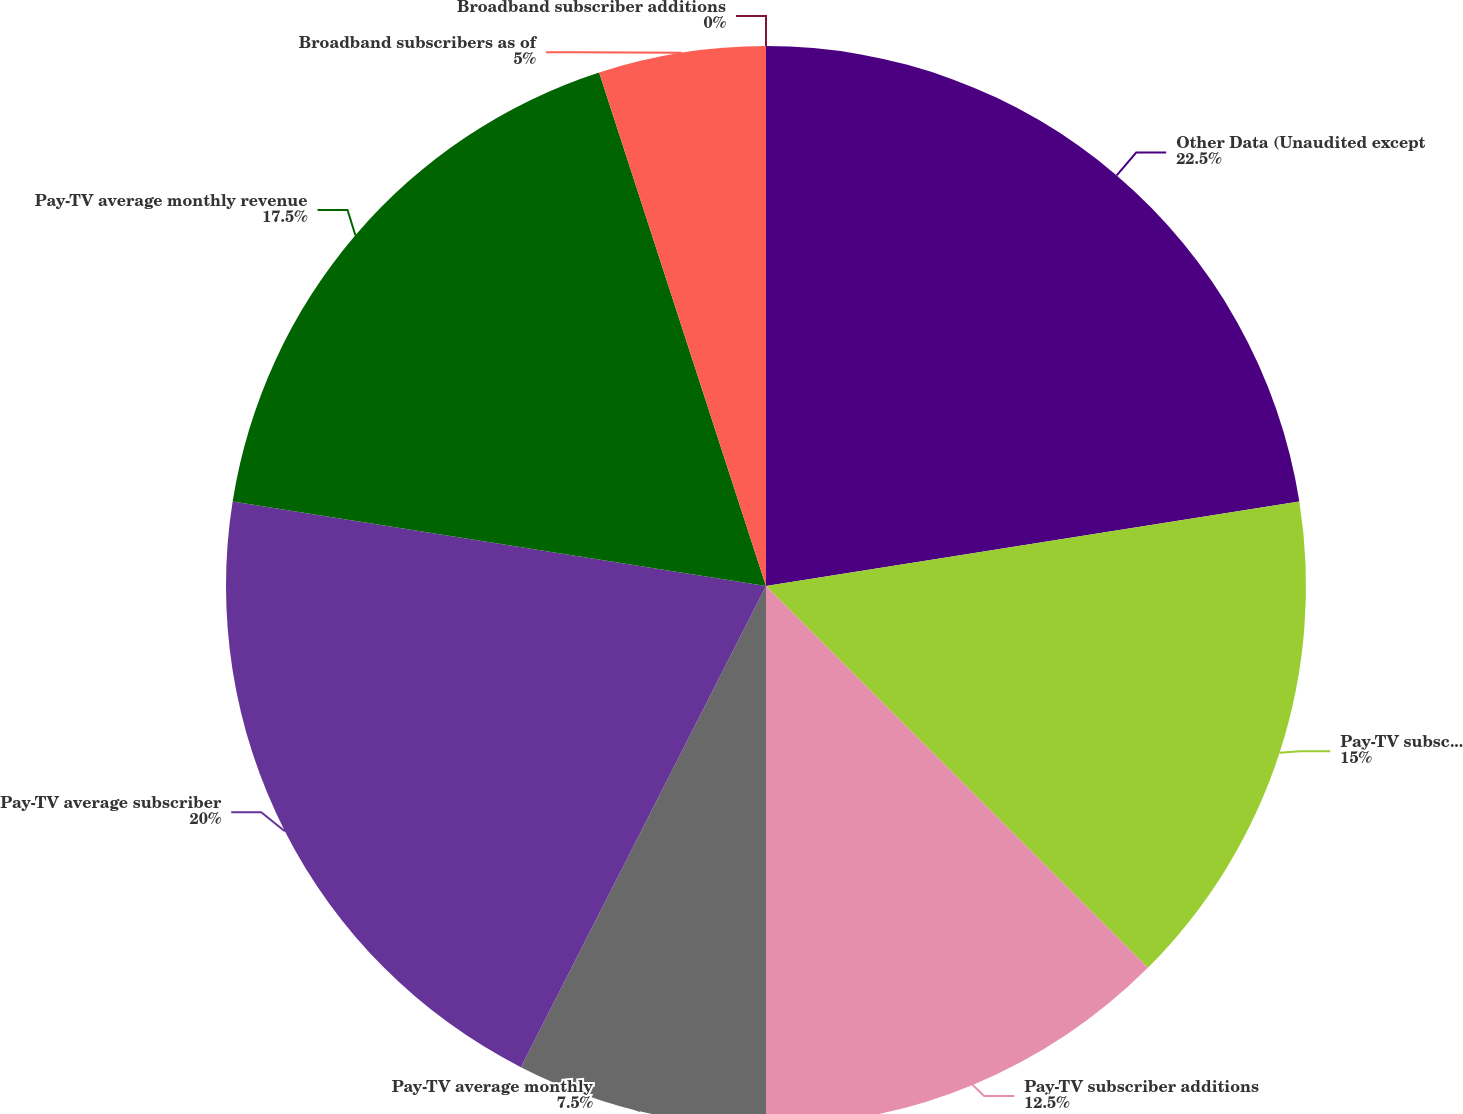Convert chart. <chart><loc_0><loc_0><loc_500><loc_500><pie_chart><fcel>Other Data (Unaudited except<fcel>Pay-TV subscribers as of<fcel>Pay-TV subscriber additions<fcel>Pay-TV average monthly<fcel>Pay-TV average subscriber<fcel>Pay-TV average monthly revenue<fcel>Broadband subscribers as of<fcel>Broadband subscriber additions<nl><fcel>22.5%<fcel>15.0%<fcel>12.5%<fcel>7.5%<fcel>20.0%<fcel>17.5%<fcel>5.0%<fcel>0.0%<nl></chart> 